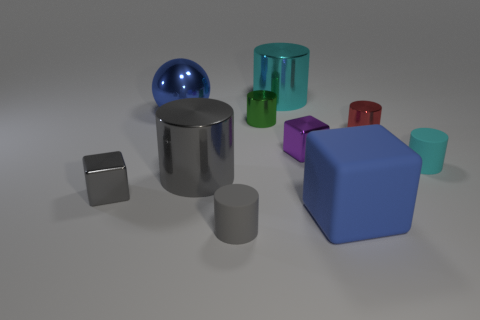Subtract all red cylinders. How many cylinders are left? 5 Subtract all big gray cylinders. How many cylinders are left? 5 Subtract 3 cylinders. How many cylinders are left? 3 Subtract all purple cylinders. Subtract all red balls. How many cylinders are left? 6 Subtract all blocks. How many objects are left? 7 Subtract all large yellow cylinders. Subtract all metallic cylinders. How many objects are left? 6 Add 4 gray rubber things. How many gray rubber things are left? 5 Add 7 gray things. How many gray things exist? 10 Subtract 0 blue cylinders. How many objects are left? 10 